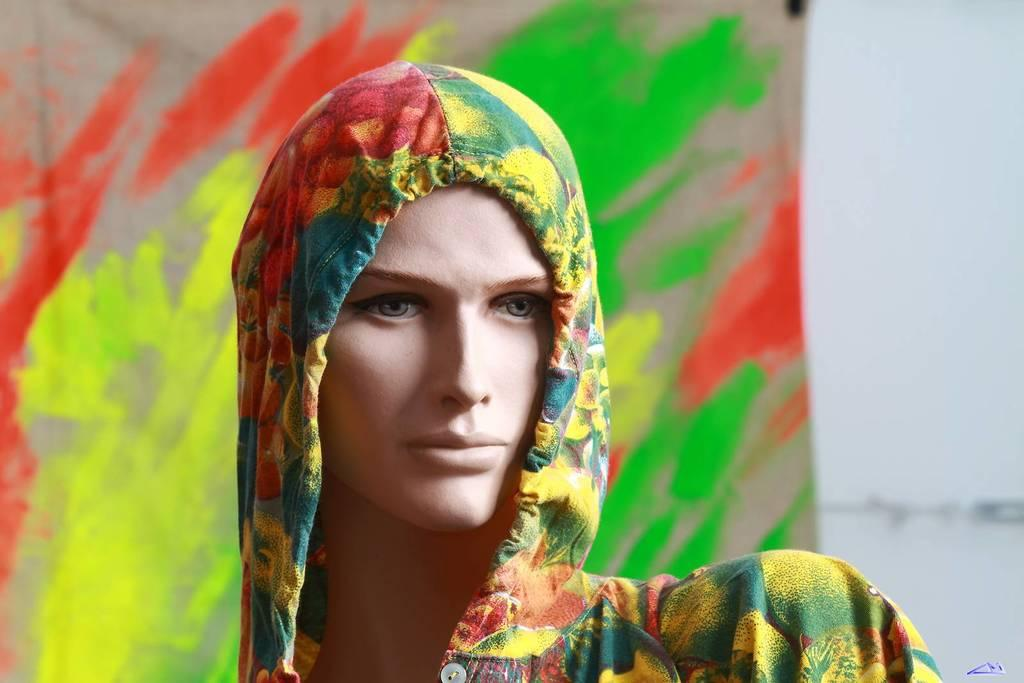Where was the image taken? The image was taken outdoors. What can be seen in the background of the image? There is a colorful cloth and a wall in the background. What is the main subject of the image? The main subject of the image is a mannequin. What is the mannequin wearing? The mannequin is wearing a hoodie. How does the mannequin express pain in the image? The mannequin does not express pain in the image, as it is an inanimate object and cannot feel or express emotions. 